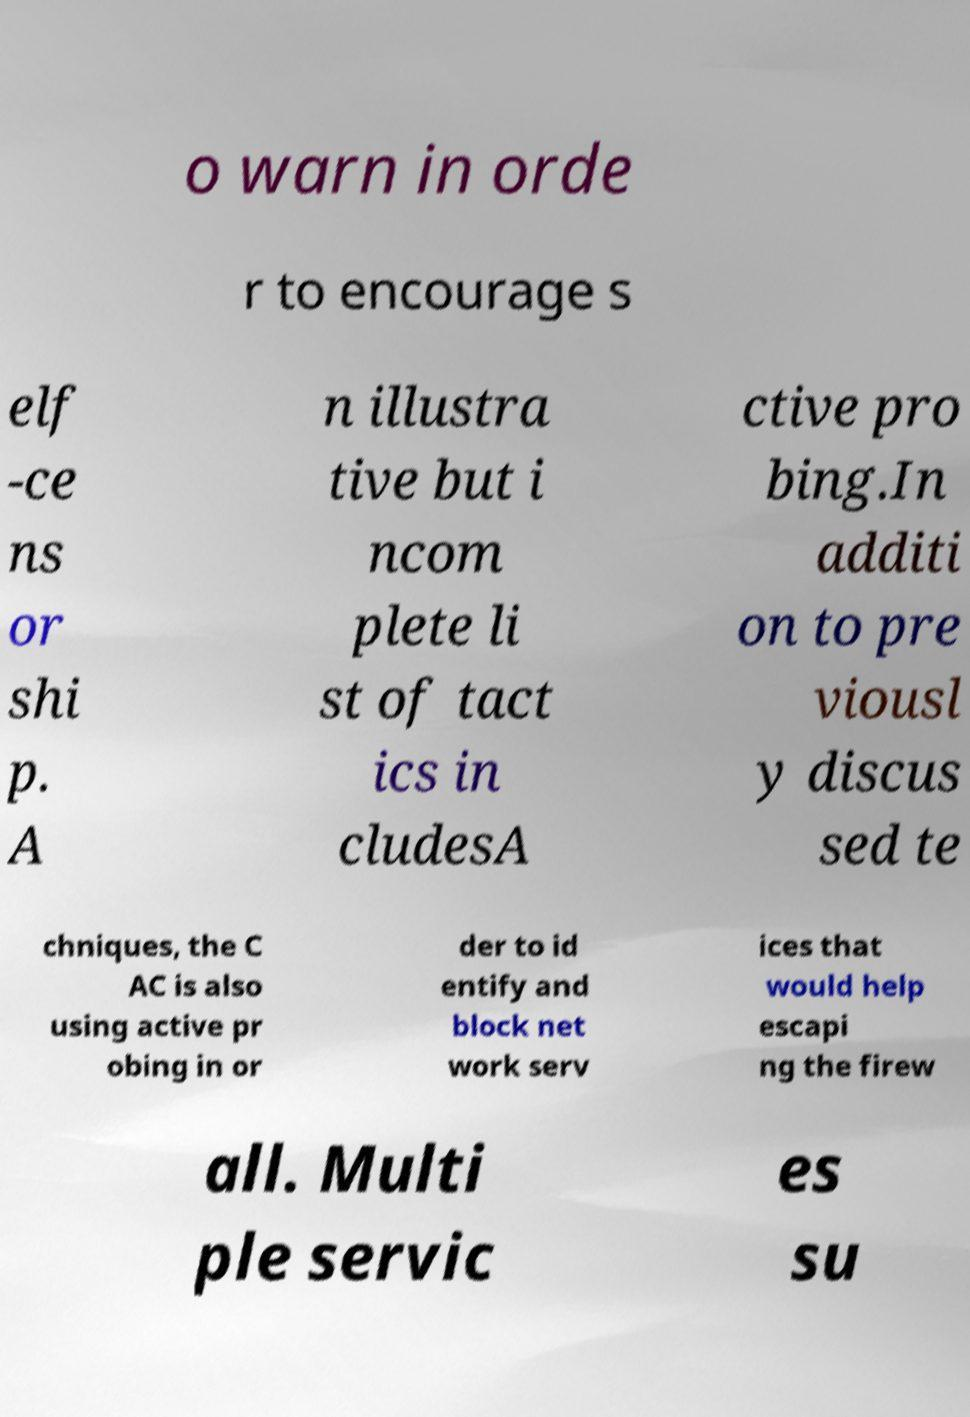Can you read and provide the text displayed in the image?This photo seems to have some interesting text. Can you extract and type it out for me? o warn in orde r to encourage s elf -ce ns or shi p. A n illustra tive but i ncom plete li st of tact ics in cludesA ctive pro bing.In additi on to pre viousl y discus sed te chniques, the C AC is also using active pr obing in or der to id entify and block net work serv ices that would help escapi ng the firew all. Multi ple servic es su 